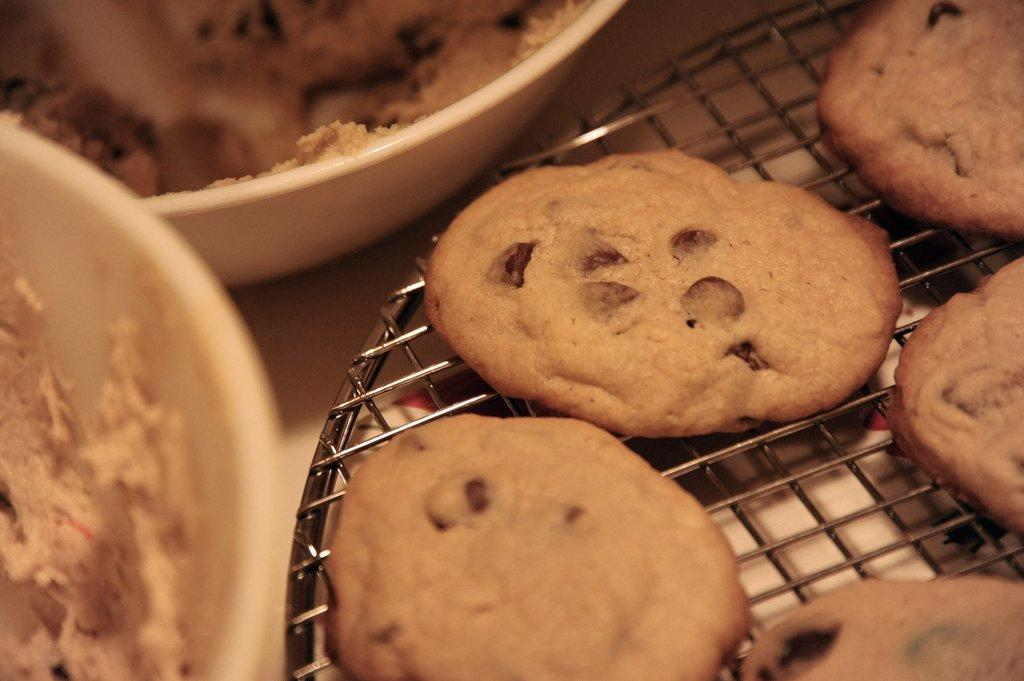What is located on the right side of the image? There is a grill with cookies on the right side of the image. What can be found on the left side of the image? There are bowls with dough on the left side of the image. What type of attraction can be seen in the image? There is no attraction present in the image; it features a grill with cookies and bowls with dough. How many crows are visible in the image? There are no crows present in the image. 